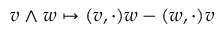<formula> <loc_0><loc_0><loc_500><loc_500>v \wedge w \mapsto ( v , \cdot ) w - ( w , \cdot ) v</formula> 